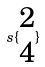<formula> <loc_0><loc_0><loc_500><loc_500>s \{ \begin{matrix} 2 \\ 4 \end{matrix} \}</formula> 